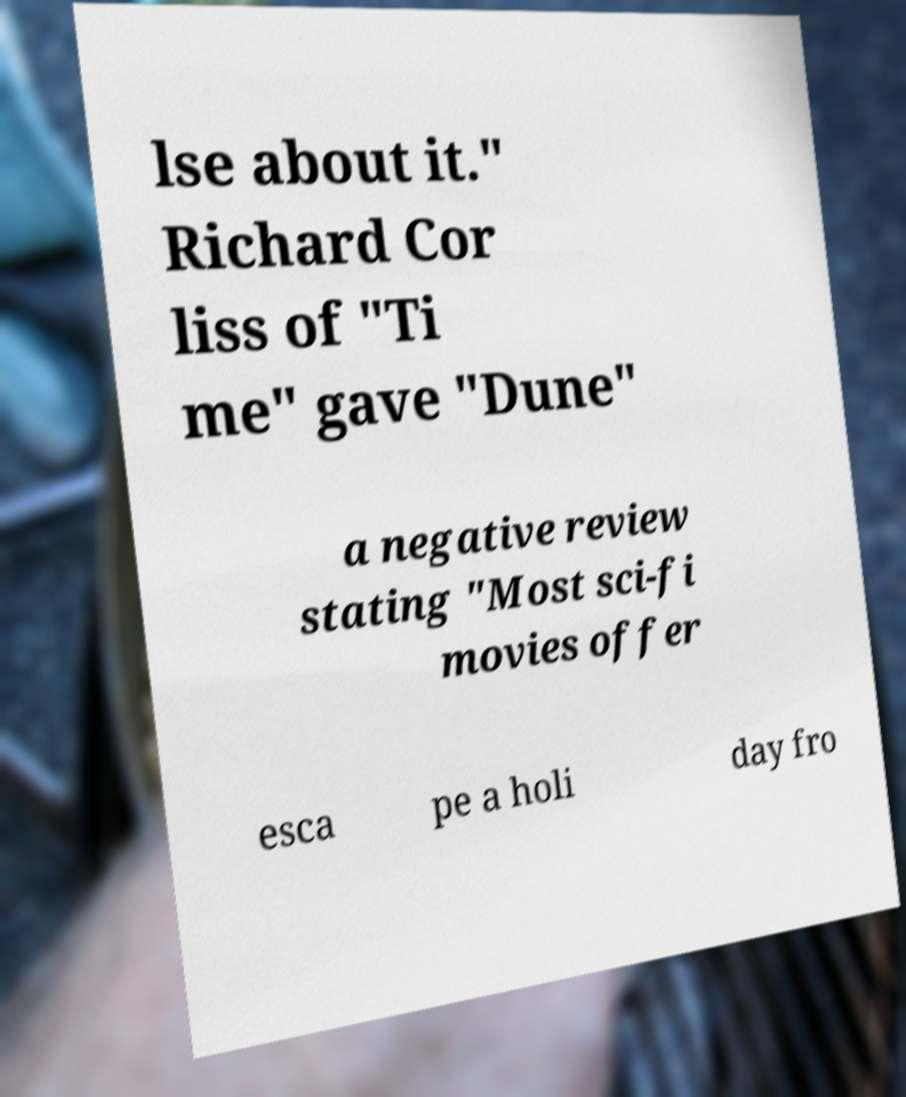Could you extract and type out the text from this image? lse about it." Richard Cor liss of "Ti me" gave "Dune" a negative review stating "Most sci-fi movies offer esca pe a holi day fro 